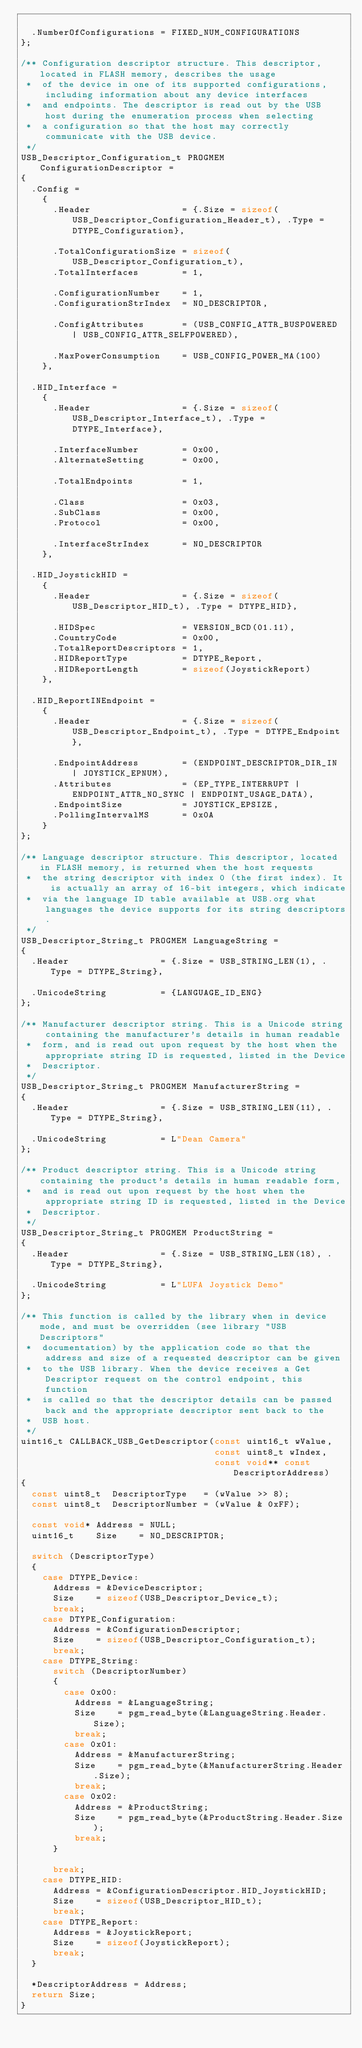Convert code to text. <code><loc_0><loc_0><loc_500><loc_500><_C_>
	.NumberOfConfigurations = FIXED_NUM_CONFIGURATIONS
};

/** Configuration descriptor structure. This descriptor, located in FLASH memory, describes the usage
 *  of the device in one of its supported configurations, including information about any device interfaces
 *  and endpoints. The descriptor is read out by the USB host during the enumeration process when selecting
 *  a configuration so that the host may correctly communicate with the USB device.
 */
USB_Descriptor_Configuration_t PROGMEM ConfigurationDescriptor =
{
	.Config =
		{
			.Header                 = {.Size = sizeof(USB_Descriptor_Configuration_Header_t), .Type = DTYPE_Configuration},

			.TotalConfigurationSize = sizeof(USB_Descriptor_Configuration_t),
			.TotalInterfaces        = 1,

			.ConfigurationNumber    = 1,
			.ConfigurationStrIndex  = NO_DESCRIPTOR,

			.ConfigAttributes       = (USB_CONFIG_ATTR_BUSPOWERED | USB_CONFIG_ATTR_SELFPOWERED),

			.MaxPowerConsumption    = USB_CONFIG_POWER_MA(100)
		},

	.HID_Interface =
		{
			.Header                 = {.Size = sizeof(USB_Descriptor_Interface_t), .Type = DTYPE_Interface},

			.InterfaceNumber        = 0x00,
			.AlternateSetting       = 0x00,

			.TotalEndpoints         = 1,

			.Class                  = 0x03,
			.SubClass               = 0x00,
			.Protocol               = 0x00,

			.InterfaceStrIndex      = NO_DESCRIPTOR
		},

	.HID_JoystickHID =
		{
			.Header                 = {.Size = sizeof(USB_Descriptor_HID_t), .Type = DTYPE_HID},

			.HIDSpec                = VERSION_BCD(01.11),
			.CountryCode            = 0x00,
			.TotalReportDescriptors = 1,
			.HIDReportType          = DTYPE_Report,
			.HIDReportLength        = sizeof(JoystickReport)
		},

	.HID_ReportINEndpoint =
		{
			.Header                 = {.Size = sizeof(USB_Descriptor_Endpoint_t), .Type = DTYPE_Endpoint},

			.EndpointAddress        = (ENDPOINT_DESCRIPTOR_DIR_IN | JOYSTICK_EPNUM),
			.Attributes             = (EP_TYPE_INTERRUPT | ENDPOINT_ATTR_NO_SYNC | ENDPOINT_USAGE_DATA),
			.EndpointSize           = JOYSTICK_EPSIZE,
			.PollingIntervalMS      = 0x0A
		}
};

/** Language descriptor structure. This descriptor, located in FLASH memory, is returned when the host requests
 *  the string descriptor with index 0 (the first index). It is actually an array of 16-bit integers, which indicate
 *  via the language ID table available at USB.org what languages the device supports for its string descriptors.
 */
USB_Descriptor_String_t PROGMEM LanguageString =
{
	.Header                 = {.Size = USB_STRING_LEN(1), .Type = DTYPE_String},

	.UnicodeString          = {LANGUAGE_ID_ENG}
};

/** Manufacturer descriptor string. This is a Unicode string containing the manufacturer's details in human readable
 *  form, and is read out upon request by the host when the appropriate string ID is requested, listed in the Device
 *  Descriptor.
 */
USB_Descriptor_String_t PROGMEM ManufacturerString =
{
	.Header                 = {.Size = USB_STRING_LEN(11), .Type = DTYPE_String},

	.UnicodeString          = L"Dean Camera"
};

/** Product descriptor string. This is a Unicode string containing the product's details in human readable form,
 *  and is read out upon request by the host when the appropriate string ID is requested, listed in the Device
 *  Descriptor.
 */
USB_Descriptor_String_t PROGMEM ProductString =
{
	.Header                 = {.Size = USB_STRING_LEN(18), .Type = DTYPE_String},

	.UnicodeString          = L"LUFA Joystick Demo"
};

/** This function is called by the library when in device mode, and must be overridden (see library "USB Descriptors"
 *  documentation) by the application code so that the address and size of a requested descriptor can be given
 *  to the USB library. When the device receives a Get Descriptor request on the control endpoint, this function
 *  is called so that the descriptor details can be passed back and the appropriate descriptor sent back to the
 *  USB host.
 */
uint16_t CALLBACK_USB_GetDescriptor(const uint16_t wValue,
                                    const uint8_t wIndex,
                                    const void** const DescriptorAddress)
{
	const uint8_t  DescriptorType   = (wValue >> 8);
	const uint8_t  DescriptorNumber = (wValue & 0xFF);

	const void* Address = NULL;
	uint16_t    Size    = NO_DESCRIPTOR;

	switch (DescriptorType)
	{
		case DTYPE_Device:
			Address = &DeviceDescriptor;
			Size    = sizeof(USB_Descriptor_Device_t);
			break;
		case DTYPE_Configuration:
			Address = &ConfigurationDescriptor;
			Size    = sizeof(USB_Descriptor_Configuration_t);
			break;
		case DTYPE_String:
			switch (DescriptorNumber)
			{
				case 0x00:
					Address = &LanguageString;
					Size    = pgm_read_byte(&LanguageString.Header.Size);
					break;
				case 0x01:
					Address = &ManufacturerString;
					Size    = pgm_read_byte(&ManufacturerString.Header.Size);
					break;
				case 0x02:
					Address = &ProductString;
					Size    = pgm_read_byte(&ProductString.Header.Size);
					break;
			}

			break;
		case DTYPE_HID:
			Address = &ConfigurationDescriptor.HID_JoystickHID;
			Size    = sizeof(USB_Descriptor_HID_t);
			break;
		case DTYPE_Report:
			Address = &JoystickReport;
			Size    = sizeof(JoystickReport);
			break;
	}

	*DescriptorAddress = Address;
	return Size;
}

</code> 